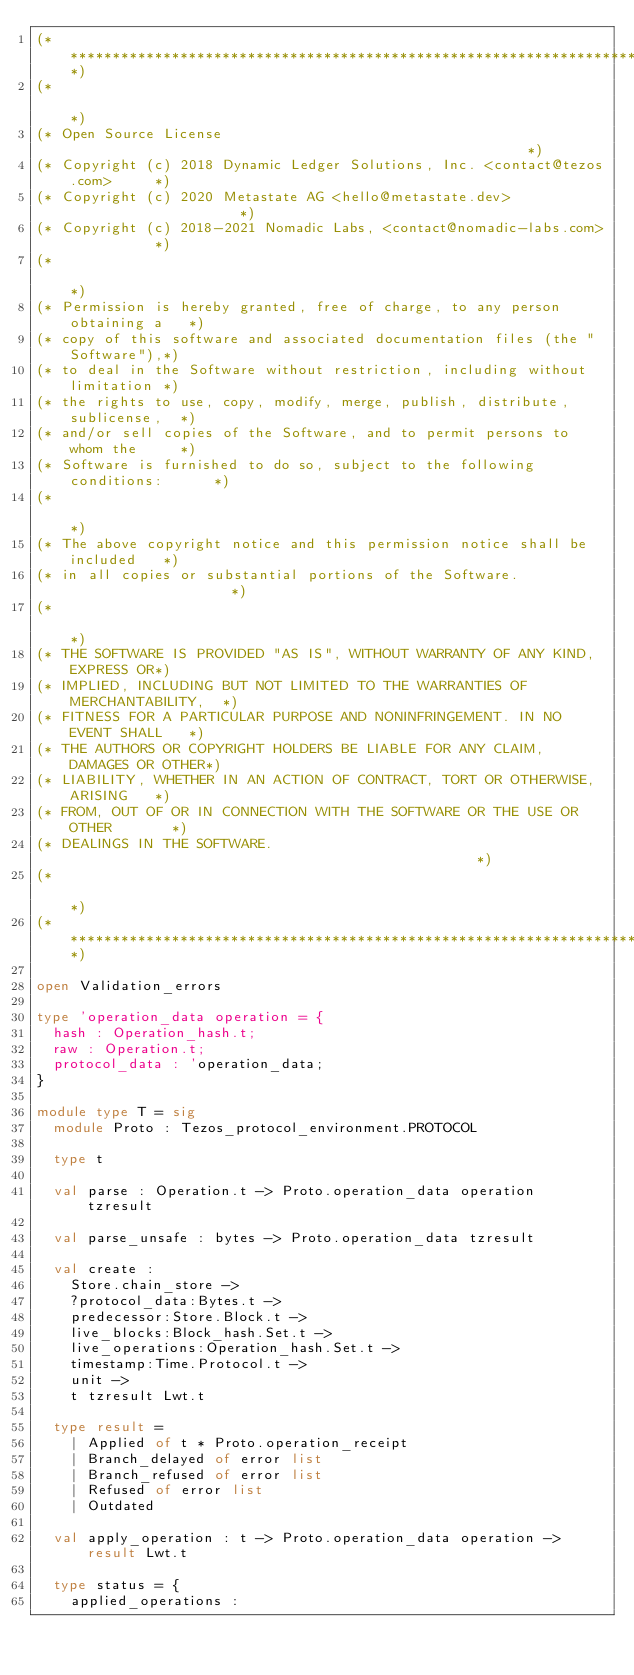Convert code to text. <code><loc_0><loc_0><loc_500><loc_500><_OCaml_>(*****************************************************************************)
(*                                                                           *)
(* Open Source License                                                       *)
(* Copyright (c) 2018 Dynamic Ledger Solutions, Inc. <contact@tezos.com>     *)
(* Copyright (c) 2020 Metastate AG <hello@metastate.dev>                     *)
(* Copyright (c) 2018-2021 Nomadic Labs, <contact@nomadic-labs.com>          *)
(*                                                                           *)
(* Permission is hereby granted, free of charge, to any person obtaining a   *)
(* copy of this software and associated documentation files (the "Software"),*)
(* to deal in the Software without restriction, including without limitation *)
(* the rights to use, copy, modify, merge, publish, distribute, sublicense,  *)
(* and/or sell copies of the Software, and to permit persons to whom the     *)
(* Software is furnished to do so, subject to the following conditions:      *)
(*                                                                           *)
(* The above copyright notice and this permission notice shall be included   *)
(* in all copies or substantial portions of the Software.                    *)
(*                                                                           *)
(* THE SOFTWARE IS PROVIDED "AS IS", WITHOUT WARRANTY OF ANY KIND, EXPRESS OR*)
(* IMPLIED, INCLUDING BUT NOT LIMITED TO THE WARRANTIES OF MERCHANTABILITY,  *)
(* FITNESS FOR A PARTICULAR PURPOSE AND NONINFRINGEMENT. IN NO EVENT SHALL   *)
(* THE AUTHORS OR COPYRIGHT HOLDERS BE LIABLE FOR ANY CLAIM, DAMAGES OR OTHER*)
(* LIABILITY, WHETHER IN AN ACTION OF CONTRACT, TORT OR OTHERWISE, ARISING   *)
(* FROM, OUT OF OR IN CONNECTION WITH THE SOFTWARE OR THE USE OR OTHER       *)
(* DEALINGS IN THE SOFTWARE.                                                 *)
(*                                                                           *)
(*****************************************************************************)

open Validation_errors

type 'operation_data operation = {
  hash : Operation_hash.t;
  raw : Operation.t;
  protocol_data : 'operation_data;
}

module type T = sig
  module Proto : Tezos_protocol_environment.PROTOCOL

  type t

  val parse : Operation.t -> Proto.operation_data operation tzresult

  val parse_unsafe : bytes -> Proto.operation_data tzresult

  val create :
    Store.chain_store ->
    ?protocol_data:Bytes.t ->
    predecessor:Store.Block.t ->
    live_blocks:Block_hash.Set.t ->
    live_operations:Operation_hash.Set.t ->
    timestamp:Time.Protocol.t ->
    unit ->
    t tzresult Lwt.t

  type result =
    | Applied of t * Proto.operation_receipt
    | Branch_delayed of error list
    | Branch_refused of error list
    | Refused of error list
    | Outdated

  val apply_operation : t -> Proto.operation_data operation -> result Lwt.t

  type status = {
    applied_operations :</code> 